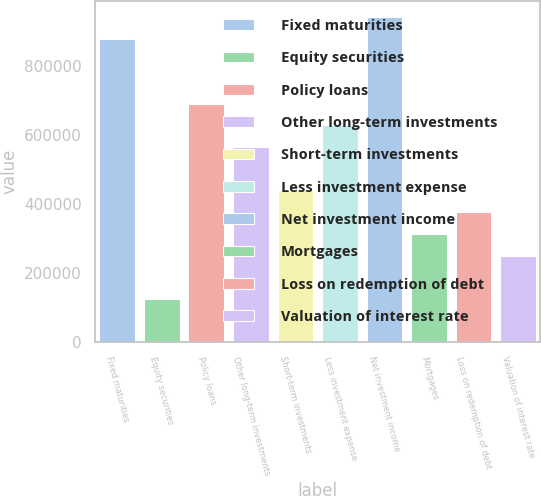<chart> <loc_0><loc_0><loc_500><loc_500><bar_chart><fcel>Fixed maturities<fcel>Equity securities<fcel>Policy loans<fcel>Other long-term investments<fcel>Short-term investments<fcel>Less investment expense<fcel>Net investment income<fcel>Mortgages<fcel>Loss on redemption of debt<fcel>Valuation of interest rate<nl><fcel>880113<fcel>126012<fcel>691588<fcel>565904<fcel>440221<fcel>628746<fcel>942955<fcel>314537<fcel>377379<fcel>251695<nl></chart> 